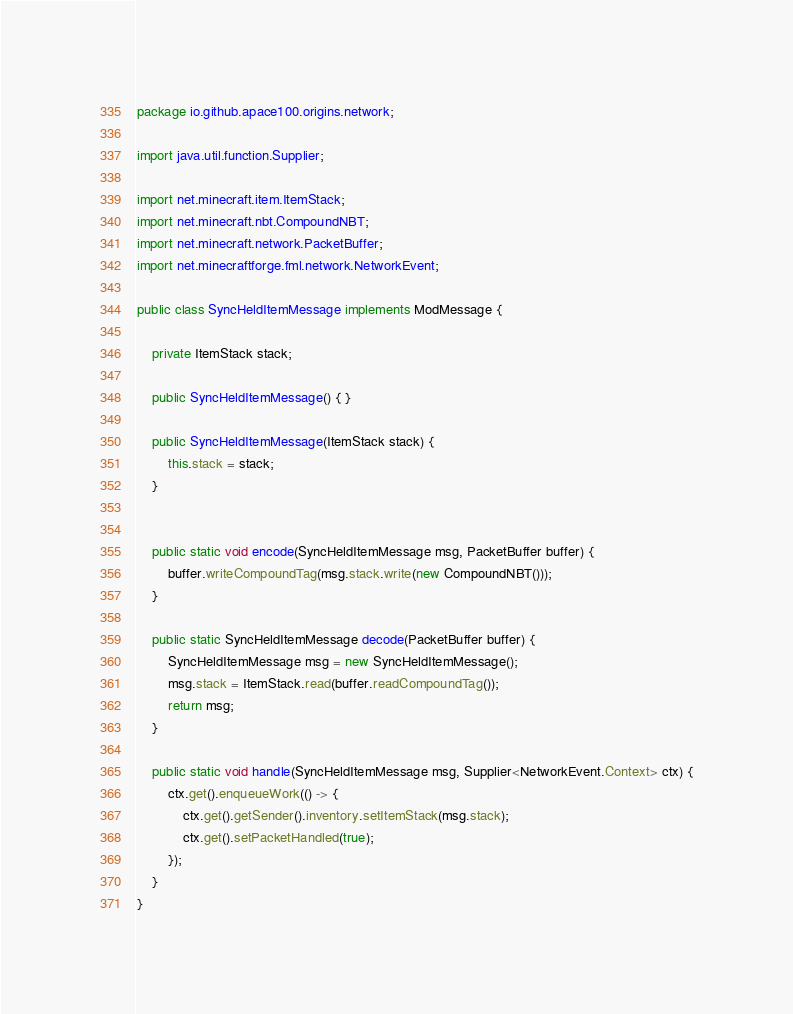Convert code to text. <code><loc_0><loc_0><loc_500><loc_500><_Java_>package io.github.apace100.origins.network;

import java.util.function.Supplier;

import net.minecraft.item.ItemStack;
import net.minecraft.nbt.CompoundNBT;
import net.minecraft.network.PacketBuffer;
import net.minecraftforge.fml.network.NetworkEvent;

public class SyncHeldItemMessage implements ModMessage {

	private ItemStack stack;

	public SyncHeldItemMessage() { }

	public SyncHeldItemMessage(ItemStack stack) {
		this.stack = stack;
	}
	

	public static void encode(SyncHeldItemMessage msg, PacketBuffer buffer) {
		buffer.writeCompoundTag(msg.stack.write(new CompoundNBT()));
	}

	public static SyncHeldItemMessage decode(PacketBuffer buffer) {
		SyncHeldItemMessage msg = new SyncHeldItemMessage();
		msg.stack = ItemStack.read(buffer.readCompoundTag());
		return msg;
	}

	public static void handle(SyncHeldItemMessage msg, Supplier<NetworkEvent.Context> ctx) {
		ctx.get().enqueueWork(() -> {
			ctx.get().getSender().inventory.setItemStack(msg.stack);
			ctx.get().setPacketHandled(true);
		});
	}
}
</code> 